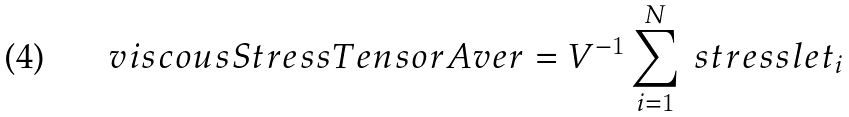Convert formula to latex. <formula><loc_0><loc_0><loc_500><loc_500>\ v i s c o u s S t r e s s T e n s o r A v e r = V ^ { - 1 } \sum _ { i = 1 } ^ { N } \ s t r e s s l e t _ { i }</formula> 